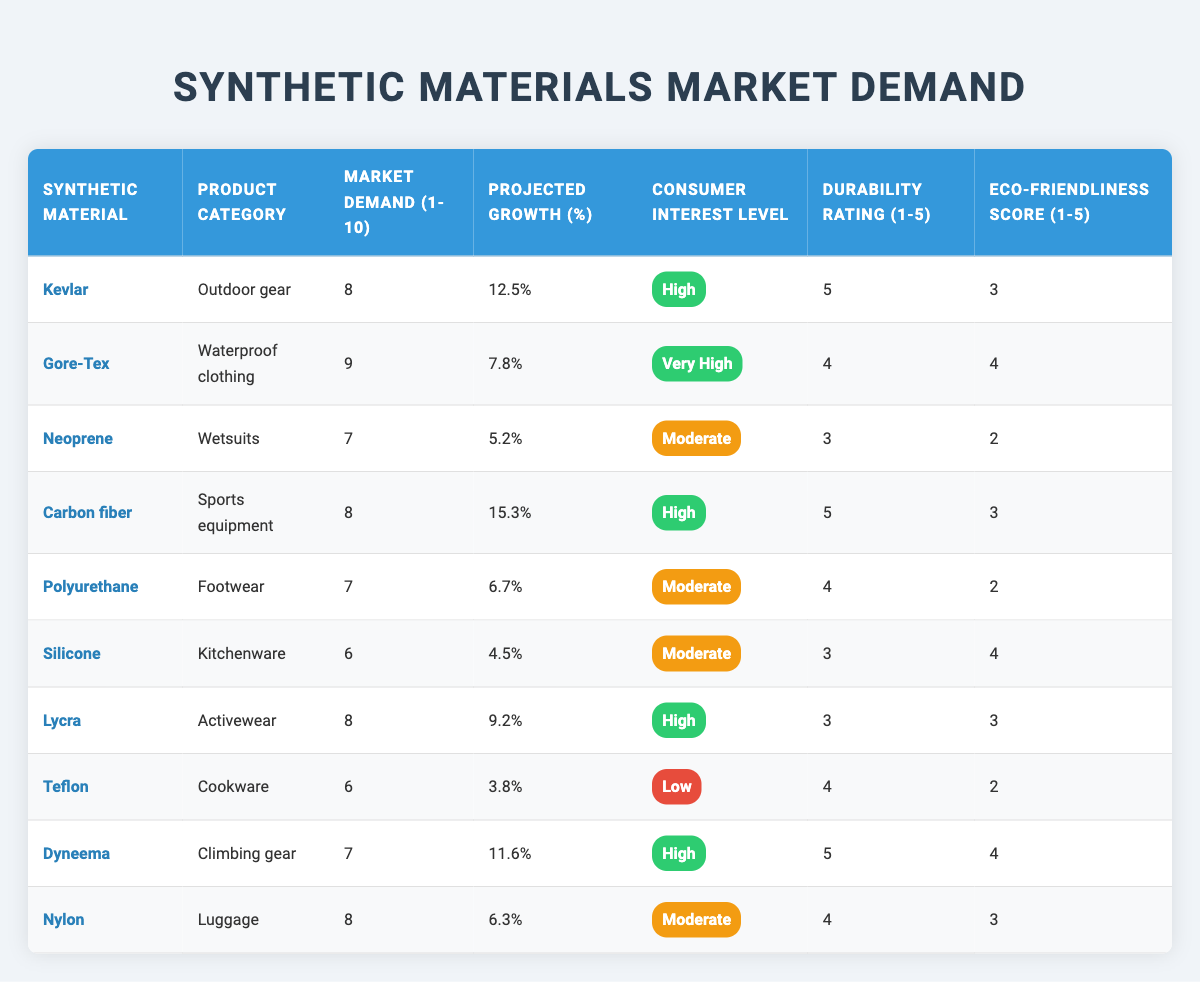What is the market demand rating for Gore-Tex? According to the table, the market demand rating for Gore-Tex is 9.
Answer: 9 Which synthetic material has the highest projected growth percentage? By examining the table, Carbon fiber has the highest projected growth percentage at 15.3%.
Answer: 15.3% Is Dyneema classified under high consumer interest level? The table indicates that Dyneema has a consumer interest level marked as "High."
Answer: Yes What is the average durability rating of all the products listed? To find the average durability rating, sum the ratings: (5 + 4 + 3 + 5 + 4 + 3 + 3 + 4 + 5 + 4) = 43. There are 10 ratings, so the average durability rating is 43 / 10 = 4.3.
Answer: 4.3 Which product category has the lowest market demand? By looking at the market demand ratings, Silicone (Kitchenware) has the lowest market demand rating at 6.
Answer: Kitchenware Are there any products with a market demand rating of 10 or higher? The table shows that no products have a market demand rating of 10 or higher, as the highest is 9.
Answer: No What is the difference in projected growth between Carbon fiber and Neoprene? Carbon fiber has a projected growth of 15.3%, and Neoprene has 5.2%. The difference is 15.3% - 5.2% = 10.1%.
Answer: 10.1% Which synthetic material has a durability rating of 3 and what is its consumer interest level? The synthetic materials with a durability rating of 3 are Neoprene, Silicone, and Lycra. Their consumer interest levels are Moderate, Moderate, and High, respectively.
Answer: Neoprene, Silicone, and Lycra How many product categories have a high eco-friendliness score? From the table, the eco-friendliness scores of the materials are: Kevlar (3), Gore-Tex (4), Neoprene (2), Carbon fiber (3), Polyurethane (2), Silicone (4), Lycra (3), Teflon (2), Dyneema (4), Nylon (3). There are 4 products (Gore-Tex, Silicone, Dyneema) that have a score of 4.
Answer: 3 What is the overall consumer interest level for products rated with a durability of 5? Products rated with a durability of 5 are Kevlar, Carbon fiber, and Dyneema. Their consumer interest levels are High, High, and High, respectively, indicating a consistent high interest level.
Answer: High 